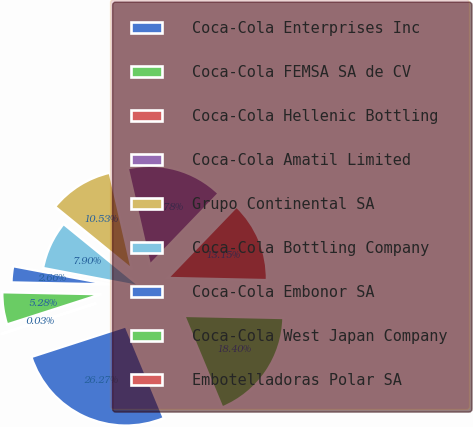Convert chart to OTSL. <chart><loc_0><loc_0><loc_500><loc_500><pie_chart><fcel>Coca-Cola Enterprises Inc<fcel>Coca-Cola FEMSA SA de CV<fcel>Coca-Cola Hellenic Bottling<fcel>Coca-Cola Amatil Limited<fcel>Grupo Continental SA<fcel>Coca-Cola Bottling Company<fcel>Coca-Cola Embonor SA<fcel>Coca-Cola West Japan Company<fcel>Embotelladoras Polar SA<nl><fcel>26.27%<fcel>18.4%<fcel>13.15%<fcel>15.78%<fcel>10.53%<fcel>7.9%<fcel>2.66%<fcel>5.28%<fcel>0.03%<nl></chart> 